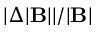Convert formula to latex. <formula><loc_0><loc_0><loc_500><loc_500>| \Delta | B | | / | B |</formula> 